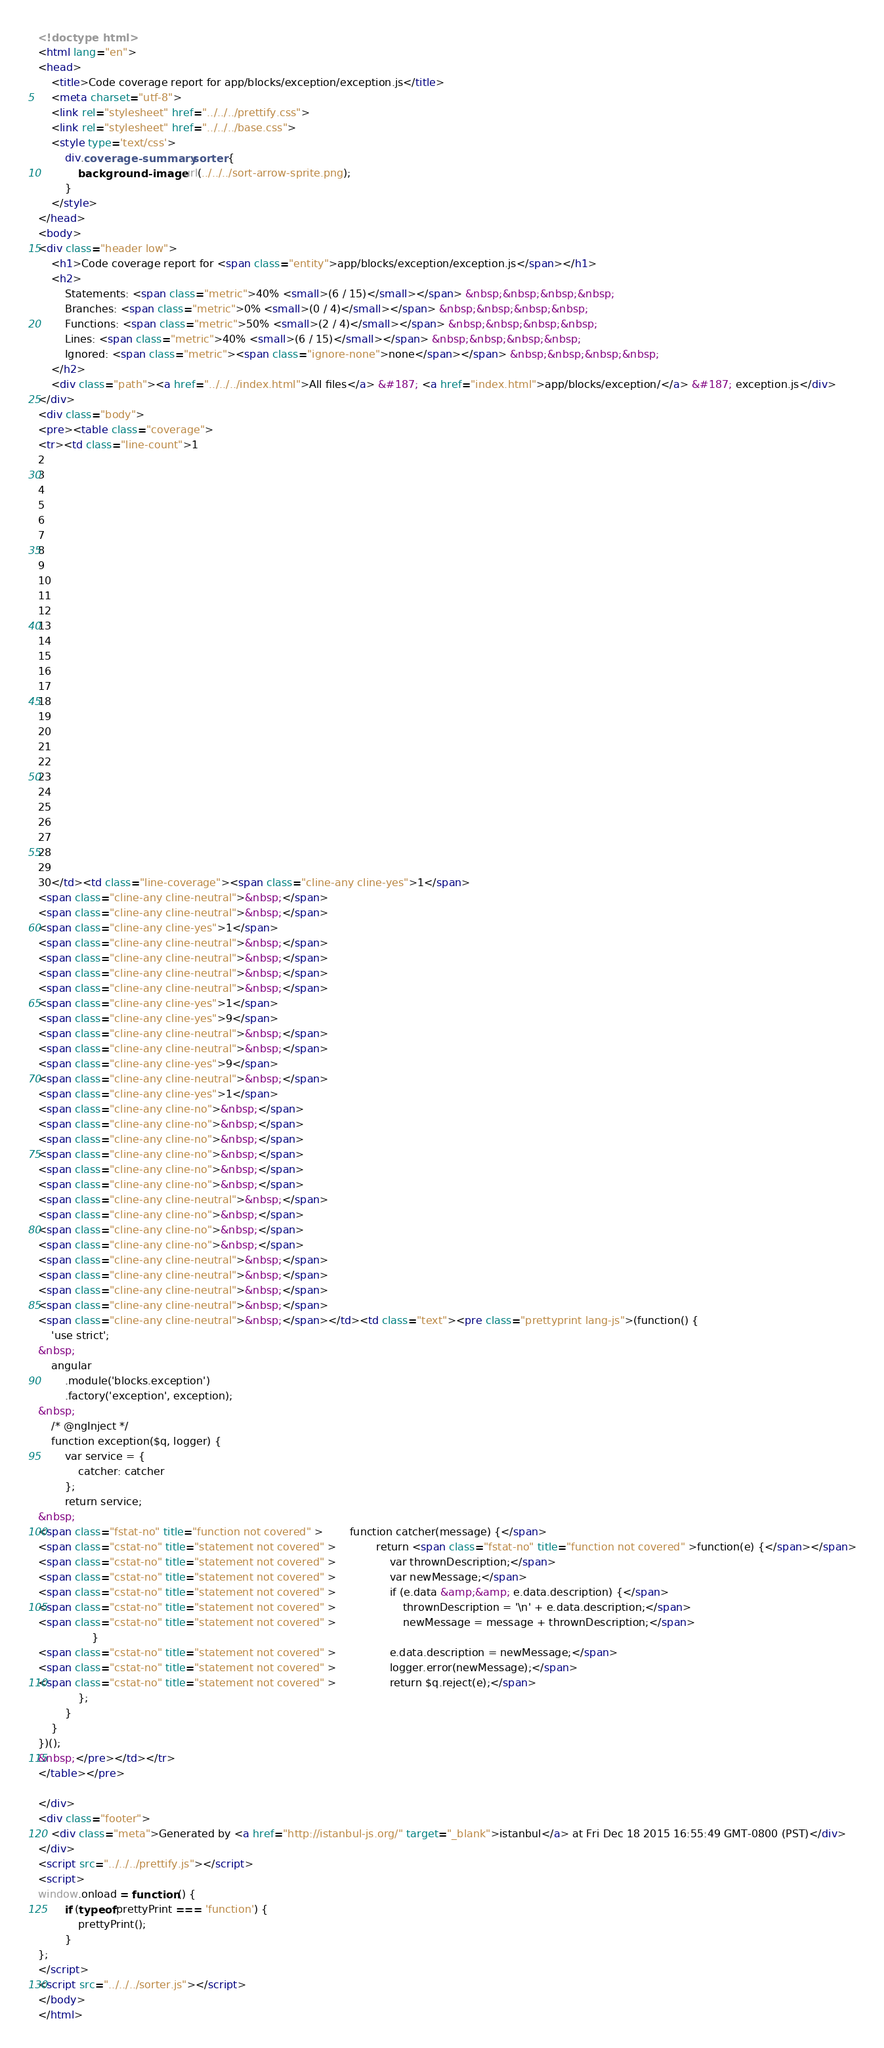<code> <loc_0><loc_0><loc_500><loc_500><_HTML_><!doctype html>
<html lang="en">
<head>
    <title>Code coverage report for app/blocks/exception/exception.js</title>
    <meta charset="utf-8">
    <link rel="stylesheet" href="../../../prettify.css">
    <link rel="stylesheet" href="../../../base.css">
    <style type='text/css'>
        div.coverage-summary .sorter {
            background-image: url(../../../sort-arrow-sprite.png);
        }
    </style>
</head>
<body>
<div class="header low">
    <h1>Code coverage report for <span class="entity">app/blocks/exception/exception.js</span></h1>
    <h2>
        Statements: <span class="metric">40% <small>(6 / 15)</small></span> &nbsp;&nbsp;&nbsp;&nbsp;
        Branches: <span class="metric">0% <small>(0 / 4)</small></span> &nbsp;&nbsp;&nbsp;&nbsp;
        Functions: <span class="metric">50% <small>(2 / 4)</small></span> &nbsp;&nbsp;&nbsp;&nbsp;
        Lines: <span class="metric">40% <small>(6 / 15)</small></span> &nbsp;&nbsp;&nbsp;&nbsp;
        Ignored: <span class="metric"><span class="ignore-none">none</span></span> &nbsp;&nbsp;&nbsp;&nbsp;
    </h2>
    <div class="path"><a href="../../../index.html">All files</a> &#187; <a href="index.html">app/blocks/exception/</a> &#187; exception.js</div>
</div>
<div class="body">
<pre><table class="coverage">
<tr><td class="line-count">1
2
3
4
5
6
7
8
9
10
11
12
13
14
15
16
17
18
19
20
21
22
23
24
25
26
27
28
29
30</td><td class="line-coverage"><span class="cline-any cline-yes">1</span>
<span class="cline-any cline-neutral">&nbsp;</span>
<span class="cline-any cline-neutral">&nbsp;</span>
<span class="cline-any cline-yes">1</span>
<span class="cline-any cline-neutral">&nbsp;</span>
<span class="cline-any cline-neutral">&nbsp;</span>
<span class="cline-any cline-neutral">&nbsp;</span>
<span class="cline-any cline-neutral">&nbsp;</span>
<span class="cline-any cline-yes">1</span>
<span class="cline-any cline-yes">9</span>
<span class="cline-any cline-neutral">&nbsp;</span>
<span class="cline-any cline-neutral">&nbsp;</span>
<span class="cline-any cline-yes">9</span>
<span class="cline-any cline-neutral">&nbsp;</span>
<span class="cline-any cline-yes">1</span>
<span class="cline-any cline-no">&nbsp;</span>
<span class="cline-any cline-no">&nbsp;</span>
<span class="cline-any cline-no">&nbsp;</span>
<span class="cline-any cline-no">&nbsp;</span>
<span class="cline-any cline-no">&nbsp;</span>
<span class="cline-any cline-no">&nbsp;</span>
<span class="cline-any cline-neutral">&nbsp;</span>
<span class="cline-any cline-no">&nbsp;</span>
<span class="cline-any cline-no">&nbsp;</span>
<span class="cline-any cline-no">&nbsp;</span>
<span class="cline-any cline-neutral">&nbsp;</span>
<span class="cline-any cline-neutral">&nbsp;</span>
<span class="cline-any cline-neutral">&nbsp;</span>
<span class="cline-any cline-neutral">&nbsp;</span>
<span class="cline-any cline-neutral">&nbsp;</span></td><td class="text"><pre class="prettyprint lang-js">(function() {
    'use strict';
&nbsp;
    angular
        .module('blocks.exception')
        .factory('exception', exception);
&nbsp;
    /* @ngInject */
    function exception($q, logger) {
        var service = {
            catcher: catcher
        };
        return service;
&nbsp;
<span class="fstat-no" title="function not covered" >        function catcher(message) {</span>
<span class="cstat-no" title="statement not covered" >            return <span class="fstat-no" title="function not covered" >function(e) {</span></span>
<span class="cstat-no" title="statement not covered" >                var thrownDescription;</span>
<span class="cstat-no" title="statement not covered" >                var newMessage;</span>
<span class="cstat-no" title="statement not covered" >                if (e.data &amp;&amp; e.data.description) {</span>
<span class="cstat-no" title="statement not covered" >                    thrownDescription = '\n' + e.data.description;</span>
<span class="cstat-no" title="statement not covered" >                    newMessage = message + thrownDescription;</span>
                }
<span class="cstat-no" title="statement not covered" >                e.data.description = newMessage;</span>
<span class="cstat-no" title="statement not covered" >                logger.error(newMessage);</span>
<span class="cstat-no" title="statement not covered" >                return $q.reject(e);</span>
            };
        }
    }
})();
&nbsp;</pre></td></tr>
</table></pre>

</div>
<div class="footer">
    <div class="meta">Generated by <a href="http://istanbul-js.org/" target="_blank">istanbul</a> at Fri Dec 18 2015 16:55:49 GMT-0800 (PST)</div>
</div>
<script src="../../../prettify.js"></script>
<script>
window.onload = function () {
        if (typeof prettyPrint === 'function') {
            prettyPrint();
        }
};
</script>
<script src="../../../sorter.js"></script>
</body>
</html>
</code> 